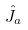<formula> <loc_0><loc_0><loc_500><loc_500>\hat { J } _ { a }</formula> 